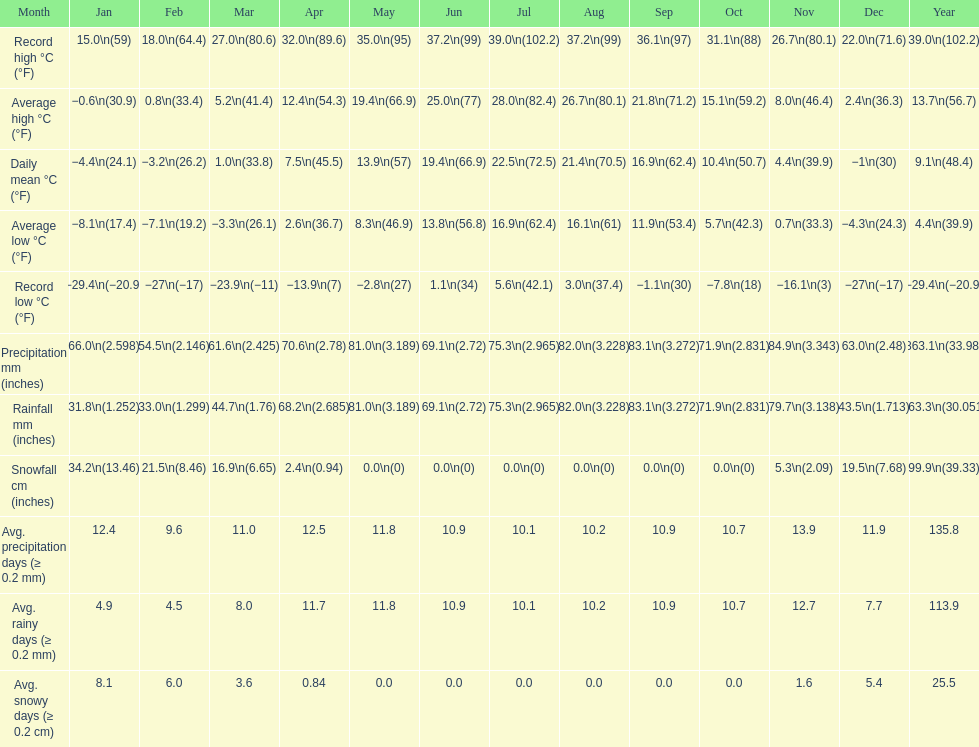1? September. 